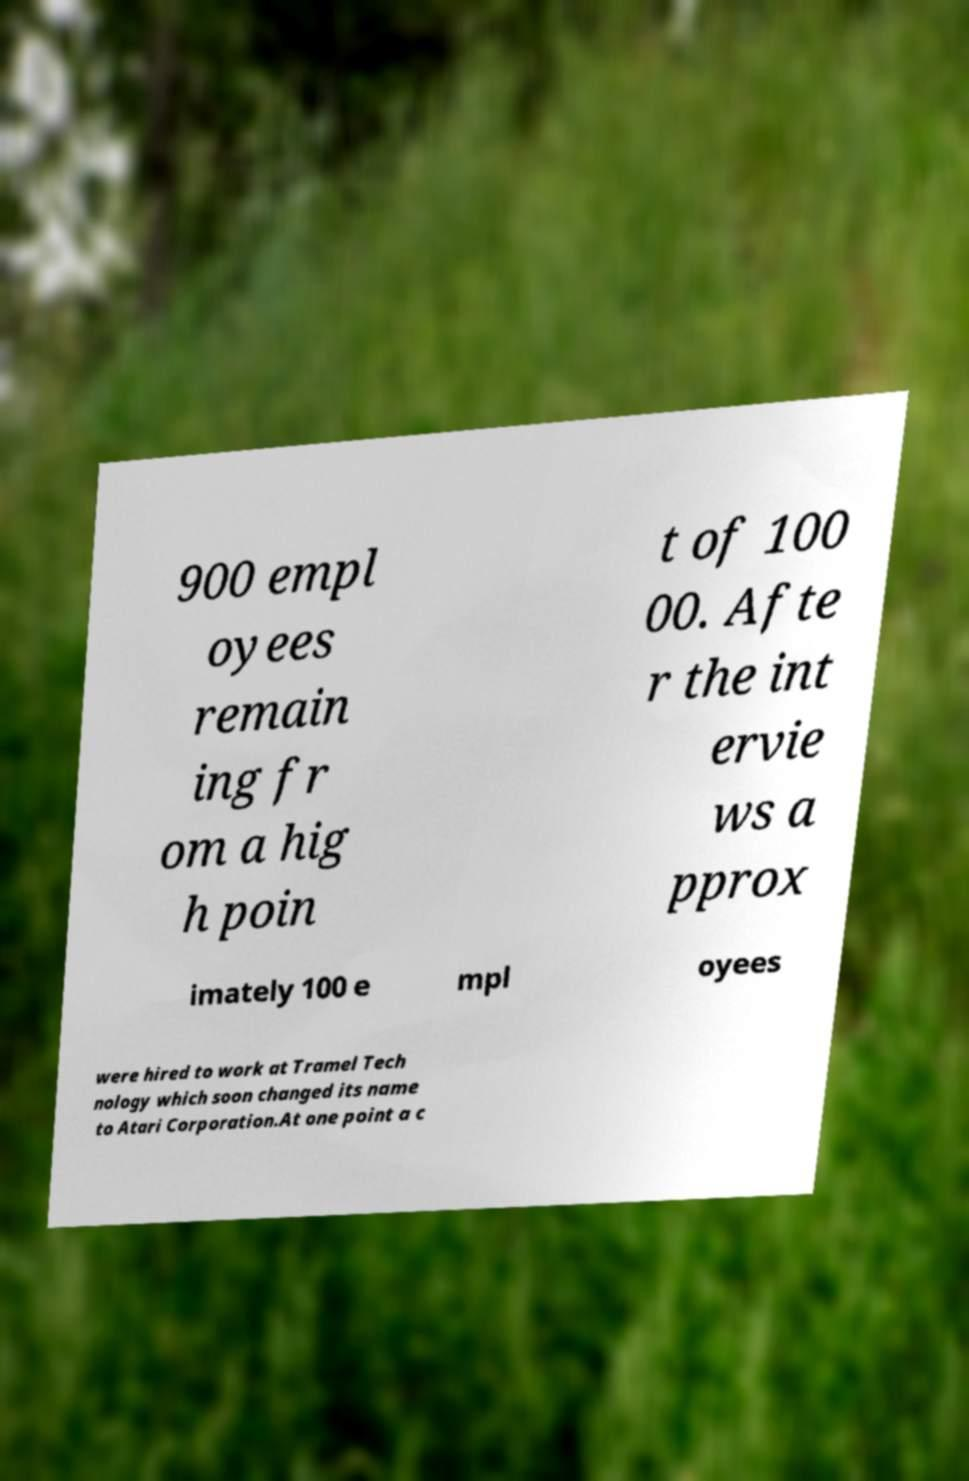For documentation purposes, I need the text within this image transcribed. Could you provide that? 900 empl oyees remain ing fr om a hig h poin t of 100 00. Afte r the int ervie ws a pprox imately 100 e mpl oyees were hired to work at Tramel Tech nology which soon changed its name to Atari Corporation.At one point a c 